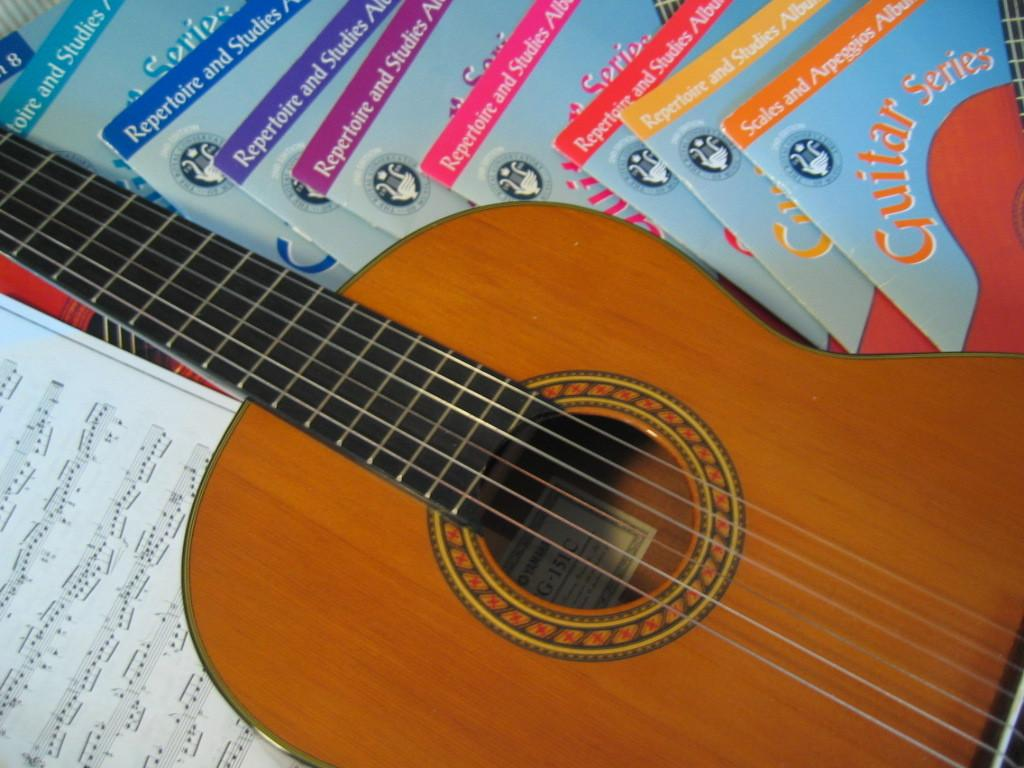What musical instrument is present in the image? There is a guitar in the image. What objects can be seen on the table in the image? There are books on the table in the image. What type of nut is growing on the guitar in the image? There is no nut growing on the guitar in the image, as it is a musical instrument and not a plant. 